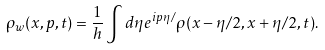<formula> <loc_0><loc_0><loc_500><loc_500>\rho _ { w } ( x , p , t ) = \frac { 1 } { h } \int d \eta e ^ { i p \eta / } \rho ( x - \eta / 2 , x + \eta / 2 , t ) .</formula> 